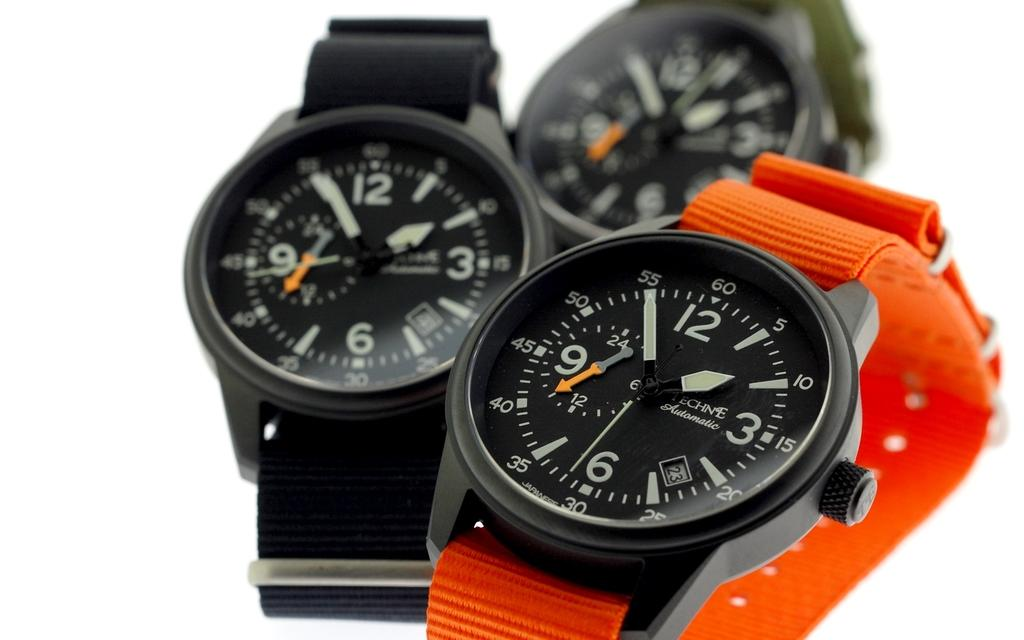<image>
Summarize the visual content of the image. A watch with an orange band says on the face that it is an automatic watch. 